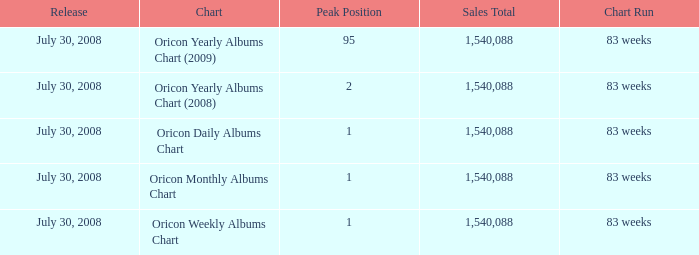Would you be able to parse every entry in this table? {'header': ['Release', 'Chart', 'Peak Position', 'Sales Total', 'Chart Run'], 'rows': [['July 30, 2008', 'Oricon Yearly Albums Chart (2009)', '95', '1,540,088', '83 weeks'], ['July 30, 2008', 'Oricon Yearly Albums Chart (2008)', '2', '1,540,088', '83 weeks'], ['July 30, 2008', 'Oricon Daily Albums Chart', '1', '1,540,088', '83 weeks'], ['July 30, 2008', 'Oricon Monthly Albums Chart', '1', '1,540,088', '83 weeks'], ['July 30, 2008', 'Oricon Weekly Albums Chart', '1', '1,540,088', '83 weeks']]} Which Sales Total has a Chart of oricon monthly albums chart? 1540088.0. 